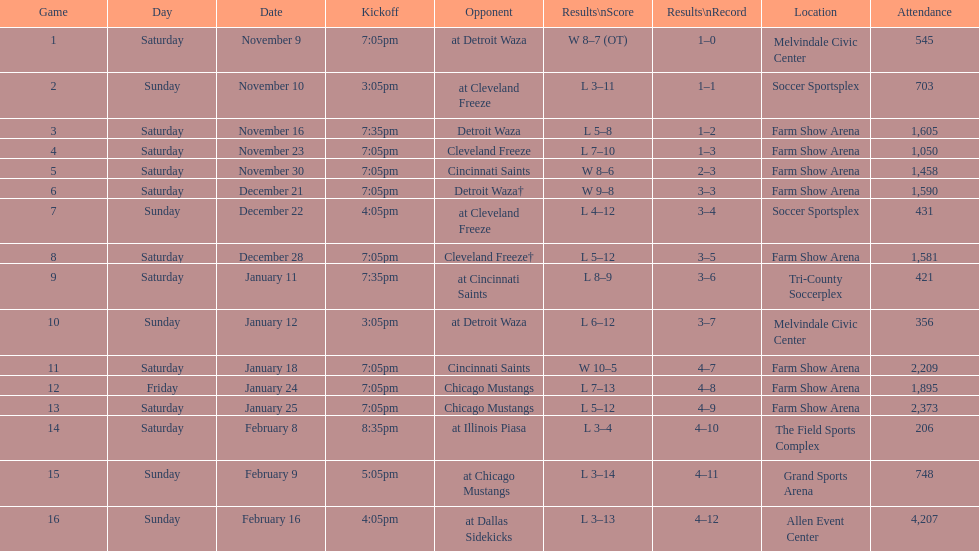What was the longest period of consecutive losses for the team? 5 games. 